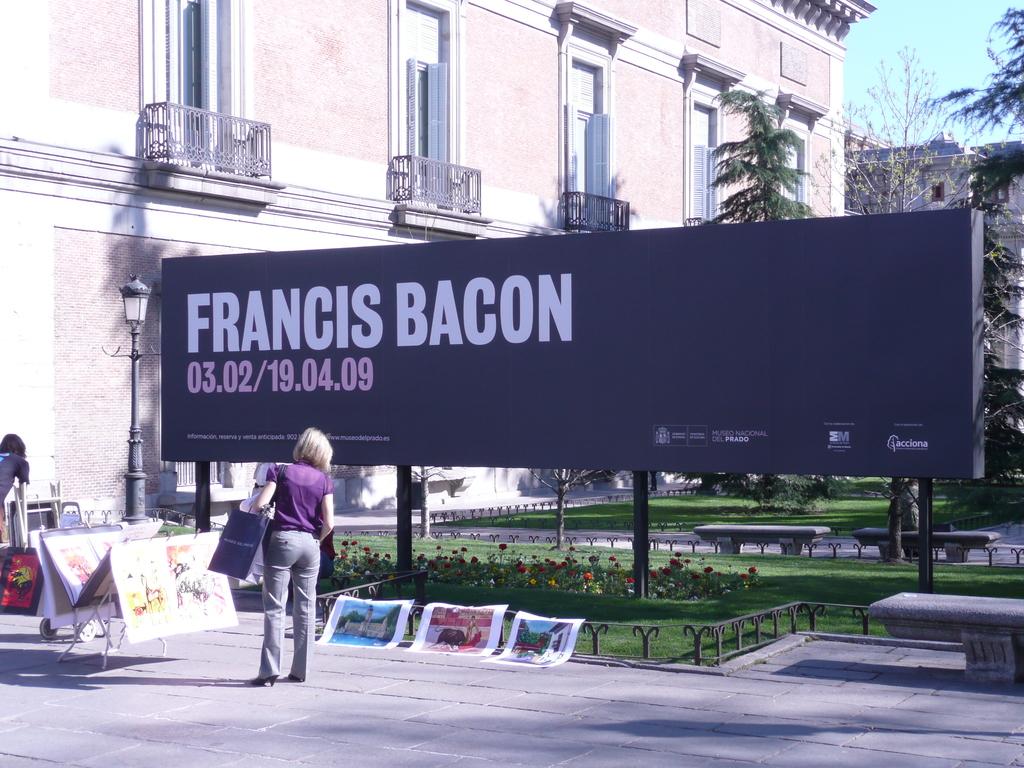What is the first date for francis bacon?
Your answer should be very brief. 03.02. Who is being advertised?
Your response must be concise. Francis bacon. 